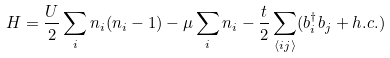<formula> <loc_0><loc_0><loc_500><loc_500>H = \frac { U } { 2 } \sum _ { i } n _ { i } ( n _ { i } - 1 ) - \mu \sum _ { i } n _ { i } - \frac { t } { 2 } \sum _ { \langle i j \rangle } ( b ^ { \dagger } _ { i } b _ { j } + h . c . )</formula> 